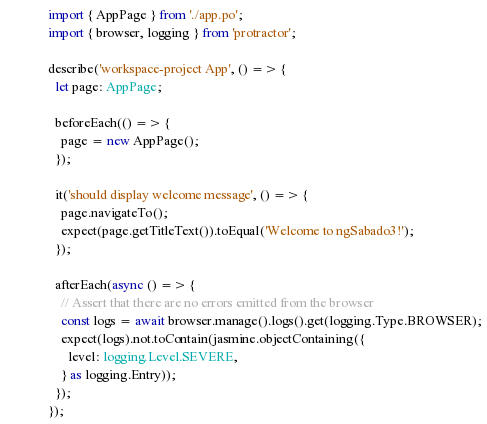<code> <loc_0><loc_0><loc_500><loc_500><_TypeScript_>import { AppPage } from './app.po';
import { browser, logging } from 'protractor';

describe('workspace-project App', () => {
  let page: AppPage;

  beforeEach(() => {
    page = new AppPage();
  });

  it('should display welcome message', () => {
    page.navigateTo();
    expect(page.getTitleText()).toEqual('Welcome to ngSabado3!');
  });

  afterEach(async () => {
    // Assert that there are no errors emitted from the browser
    const logs = await browser.manage().logs().get(logging.Type.BROWSER);
    expect(logs).not.toContain(jasmine.objectContaining({
      level: logging.Level.SEVERE,
    } as logging.Entry));
  });
});
</code> 